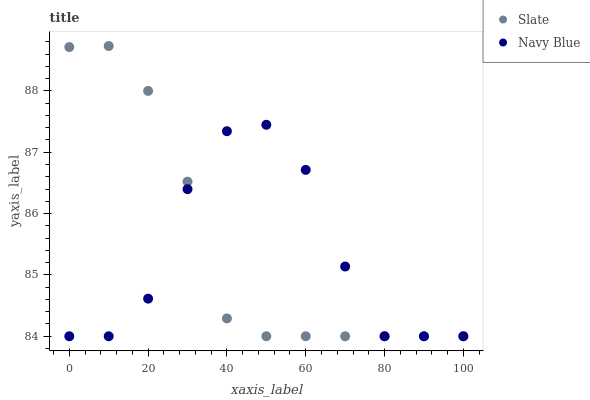Does Navy Blue have the minimum area under the curve?
Answer yes or no. Yes. Does Slate have the maximum area under the curve?
Answer yes or no. Yes. Does Slate have the minimum area under the curve?
Answer yes or no. No. Is Slate the smoothest?
Answer yes or no. Yes. Is Navy Blue the roughest?
Answer yes or no. Yes. Is Slate the roughest?
Answer yes or no. No. Does Navy Blue have the lowest value?
Answer yes or no. Yes. Does Slate have the highest value?
Answer yes or no. Yes. Does Slate intersect Navy Blue?
Answer yes or no. Yes. Is Slate less than Navy Blue?
Answer yes or no. No. Is Slate greater than Navy Blue?
Answer yes or no. No. 